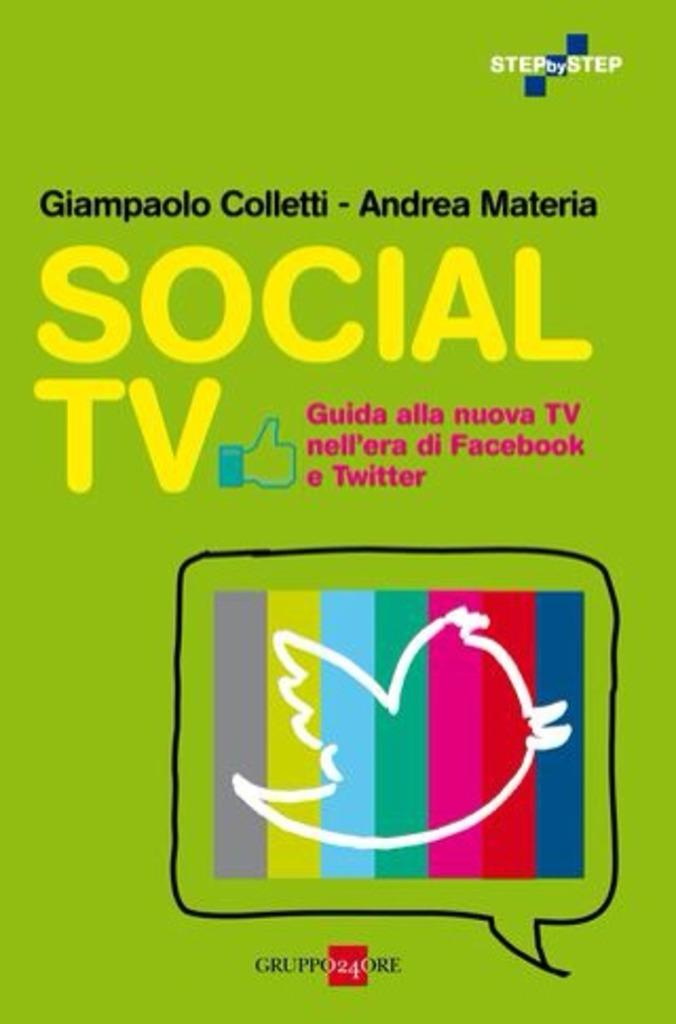Provide a one-sentence caption for the provided image. a cartoon tv that says social tv on it. 